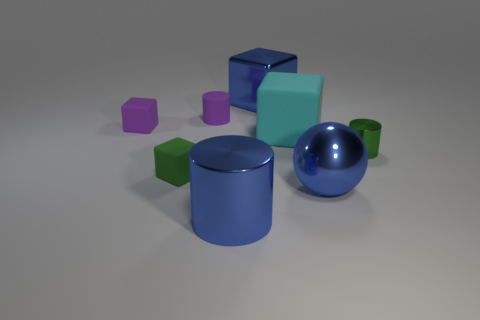Subtract 1 cylinders. How many cylinders are left? 2 Subtract all purple blocks. How many blocks are left? 3 Subtract all tiny cylinders. How many cylinders are left? 1 Add 1 blue blocks. How many objects exist? 9 Subtract all yellow cubes. Subtract all gray cylinders. How many cubes are left? 4 Subtract all cylinders. How many objects are left? 5 Add 3 tiny metallic things. How many tiny metallic things are left? 4 Add 6 shiny blocks. How many shiny blocks exist? 7 Subtract 0 brown blocks. How many objects are left? 8 Subtract all small purple objects. Subtract all green objects. How many objects are left? 4 